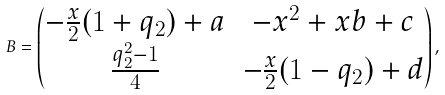Convert formula to latex. <formula><loc_0><loc_0><loc_500><loc_500>B = \begin{pmatrix} - \frac { x } { 2 } ( 1 + q _ { 2 } ) + { a } & - x ^ { 2 } + x b + c \\ \frac { q _ { 2 } ^ { 2 } - 1 } { 4 } & - \frac { x } { 2 } ( 1 - q _ { 2 } ) + { d } \end{pmatrix} ,</formula> 